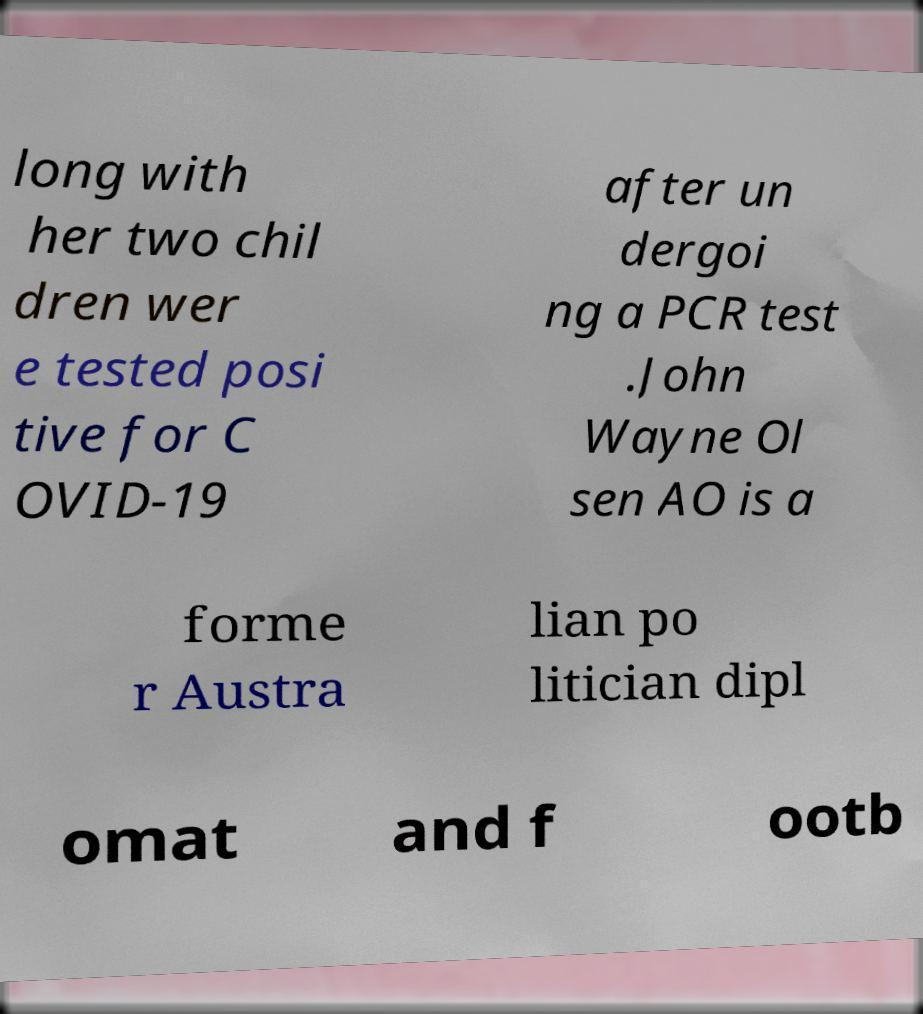What messages or text are displayed in this image? I need them in a readable, typed format. long with her two chil dren wer e tested posi tive for C OVID-19 after un dergoi ng a PCR test .John Wayne Ol sen AO is a forme r Austra lian po litician dipl omat and f ootb 